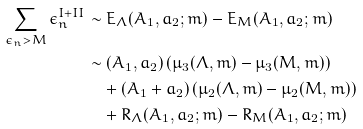<formula> <loc_0><loc_0><loc_500><loc_500>\sum _ { \epsilon _ { n } > M } \epsilon _ { n } ^ { I + I I } & \sim E _ { \Lambda } ( A _ { 1 } , a _ { 2 } ; m ) - E _ { M } ( A _ { 1 } , a _ { 2 } ; m ) \\ & \sim ( A _ { 1 } , a _ { 2 } ) \left ( \mu _ { 3 } ( \Lambda , m ) - \mu _ { 3 } ( M , m ) \right ) \\ & \quad + ( A _ { 1 } + a _ { 2 } ) \left ( \mu _ { 2 } ( \Lambda , m ) - \mu _ { 2 } ( M , m ) \right ) \\ & \quad + R _ { \Lambda } ( A _ { 1 } , a _ { 2 } ; m ) - R _ { M } ( A _ { 1 } , a _ { 2 } ; m )</formula> 